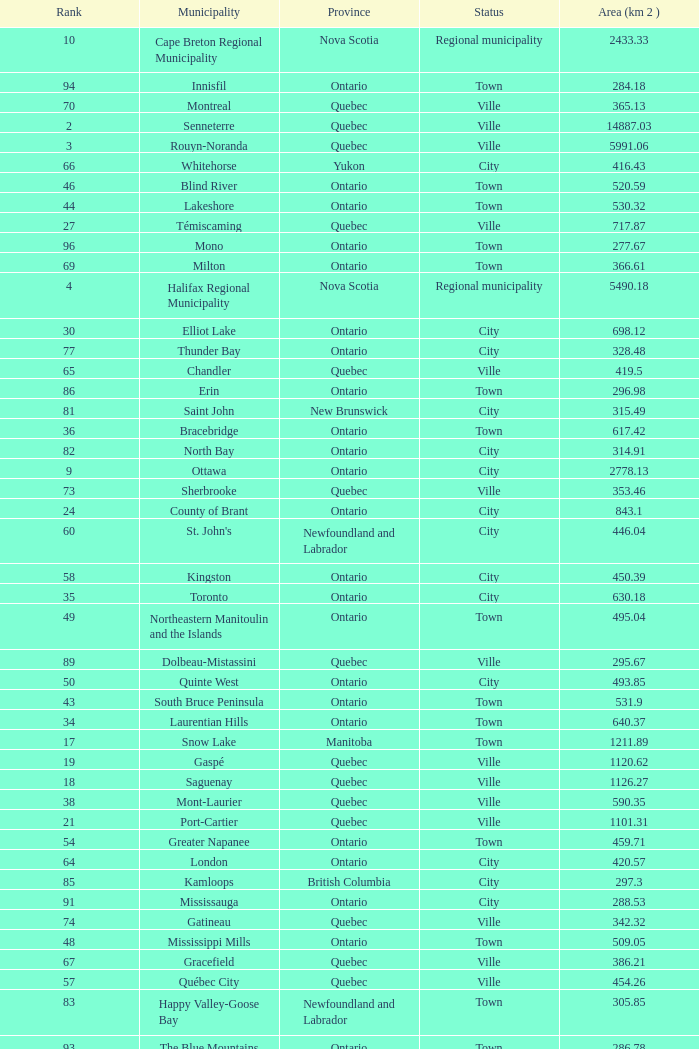What's the total of Rank that has an Area (KM 2) of 1050.14? 22.0. 